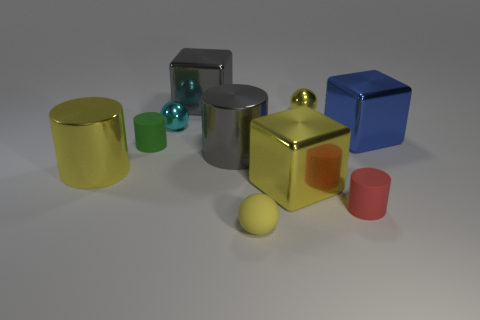How many things are gray shiny objects behind the blue metal object or tiny balls that are behind the yellow cylinder?
Offer a very short reply. 3. Is there a gray metal ball that has the same size as the green thing?
Give a very brief answer. No. There is another tiny matte object that is the same shape as the red rubber thing; what is its color?
Your answer should be very brief. Green. There is a object in front of the small red rubber thing; is there a cyan thing in front of it?
Your answer should be very brief. No. There is a large metallic thing that is on the right side of the small red thing; does it have the same shape as the cyan object?
Your response must be concise. No. There is a red rubber object; what shape is it?
Your answer should be very brief. Cylinder. How many tiny yellow spheres are made of the same material as the red thing?
Ensure brevity in your answer.  1. There is a rubber ball; is it the same color as the metallic cylinder to the left of the tiny green cylinder?
Provide a succinct answer. Yes. How many tiny yellow matte things are there?
Your answer should be very brief. 1. Is there a rubber thing that has the same color as the matte sphere?
Offer a very short reply. No. 